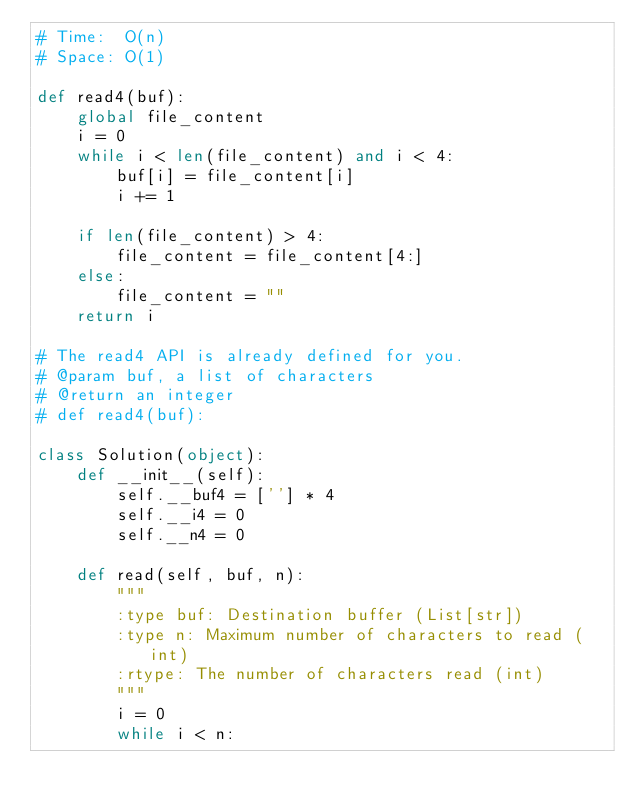Convert code to text. <code><loc_0><loc_0><loc_500><loc_500><_Python_># Time:  O(n)
# Space: O(1)

def read4(buf):
    global file_content
    i = 0
    while i < len(file_content) and i < 4:
        buf[i] = file_content[i]
        i += 1

    if len(file_content) > 4:
        file_content = file_content[4:]
    else:
        file_content = ""
    return i

# The read4 API is already defined for you.
# @param buf, a list of characters
# @return an integer
# def read4(buf):

class Solution(object):
    def __init__(self):
        self.__buf4 = [''] * 4
        self.__i4 = 0
        self.__n4 = 0

    def read(self, buf, n):
        """
        :type buf: Destination buffer (List[str])
        :type n: Maximum number of characters to read (int)
        :rtype: The number of characters read (int)
        """
        i = 0
        while i < n:</code> 